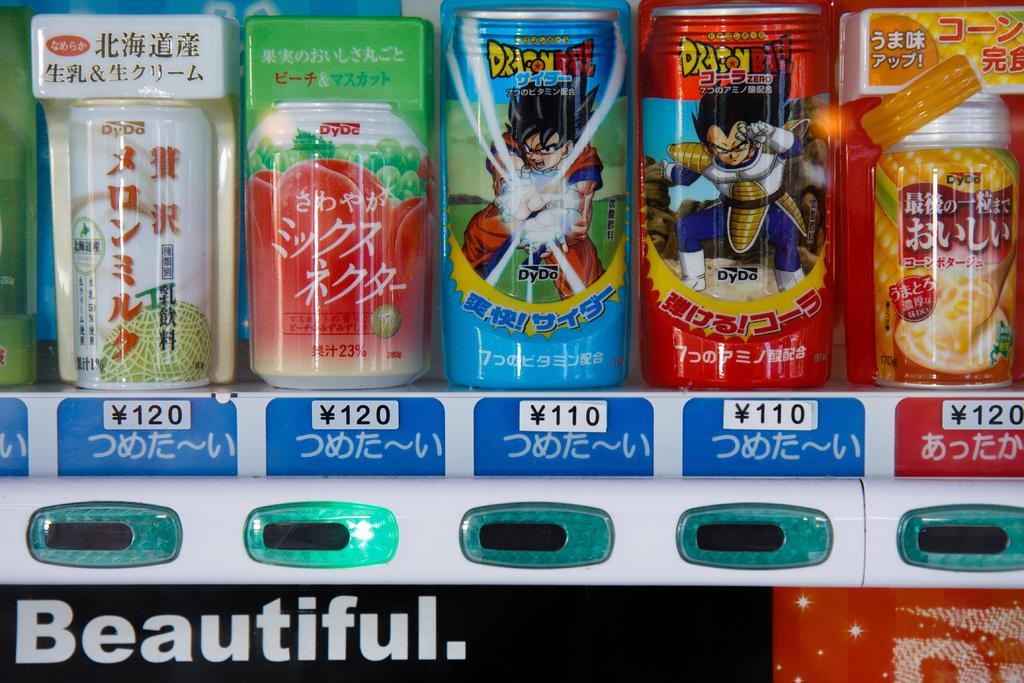Please provide a concise description of this image. In this image we can see beverages tins. 